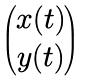Convert formula to latex. <formula><loc_0><loc_0><loc_500><loc_500>\begin{pmatrix} x ( t ) \\ y ( t ) \end{pmatrix}</formula> 